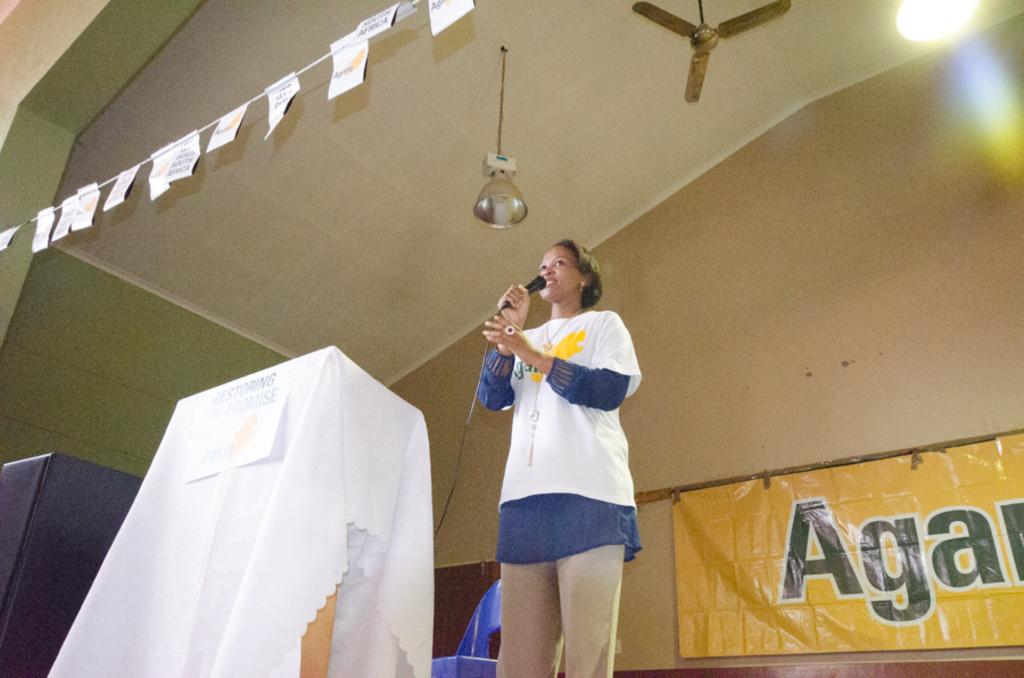What does the writing read?
Offer a terse response. Aga. 